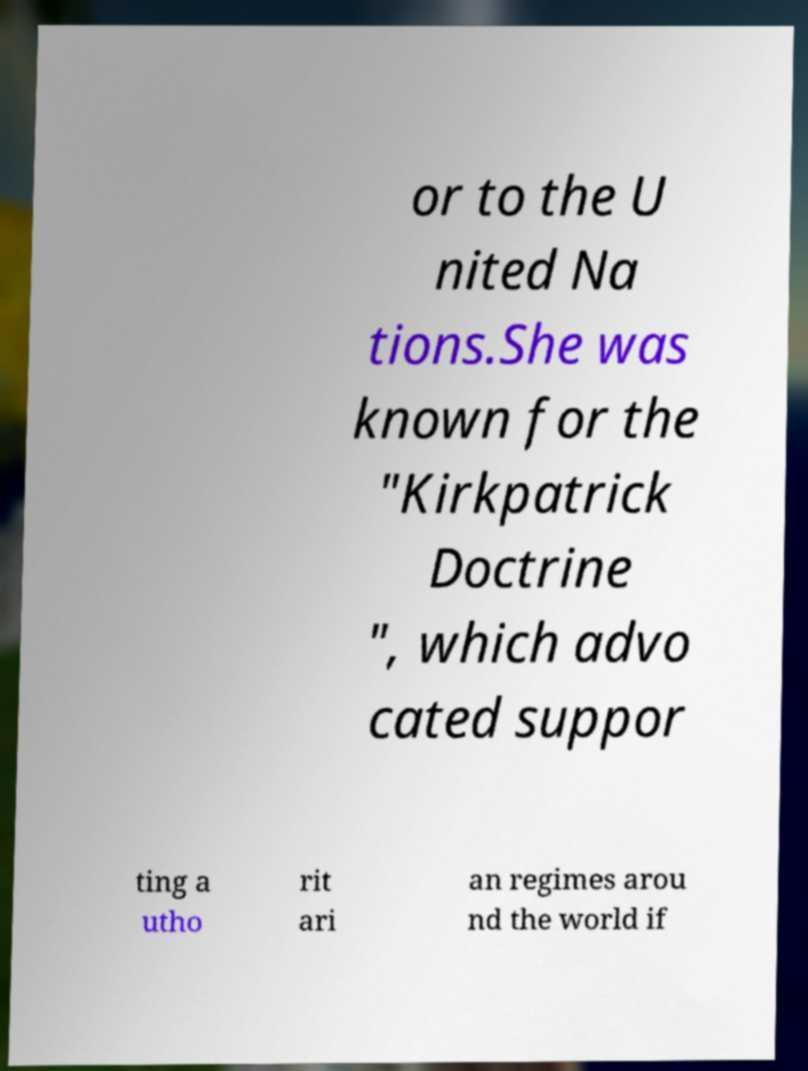There's text embedded in this image that I need extracted. Can you transcribe it verbatim? or to the U nited Na tions.She was known for the "Kirkpatrick Doctrine ", which advo cated suppor ting a utho rit ari an regimes arou nd the world if 